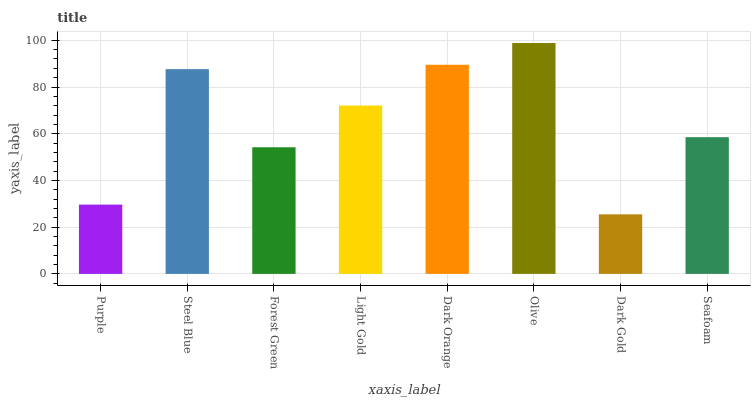Is Dark Gold the minimum?
Answer yes or no. Yes. Is Olive the maximum?
Answer yes or no. Yes. Is Steel Blue the minimum?
Answer yes or no. No. Is Steel Blue the maximum?
Answer yes or no. No. Is Steel Blue greater than Purple?
Answer yes or no. Yes. Is Purple less than Steel Blue?
Answer yes or no. Yes. Is Purple greater than Steel Blue?
Answer yes or no. No. Is Steel Blue less than Purple?
Answer yes or no. No. Is Light Gold the high median?
Answer yes or no. Yes. Is Seafoam the low median?
Answer yes or no. Yes. Is Dark Orange the high median?
Answer yes or no. No. Is Steel Blue the low median?
Answer yes or no. No. 